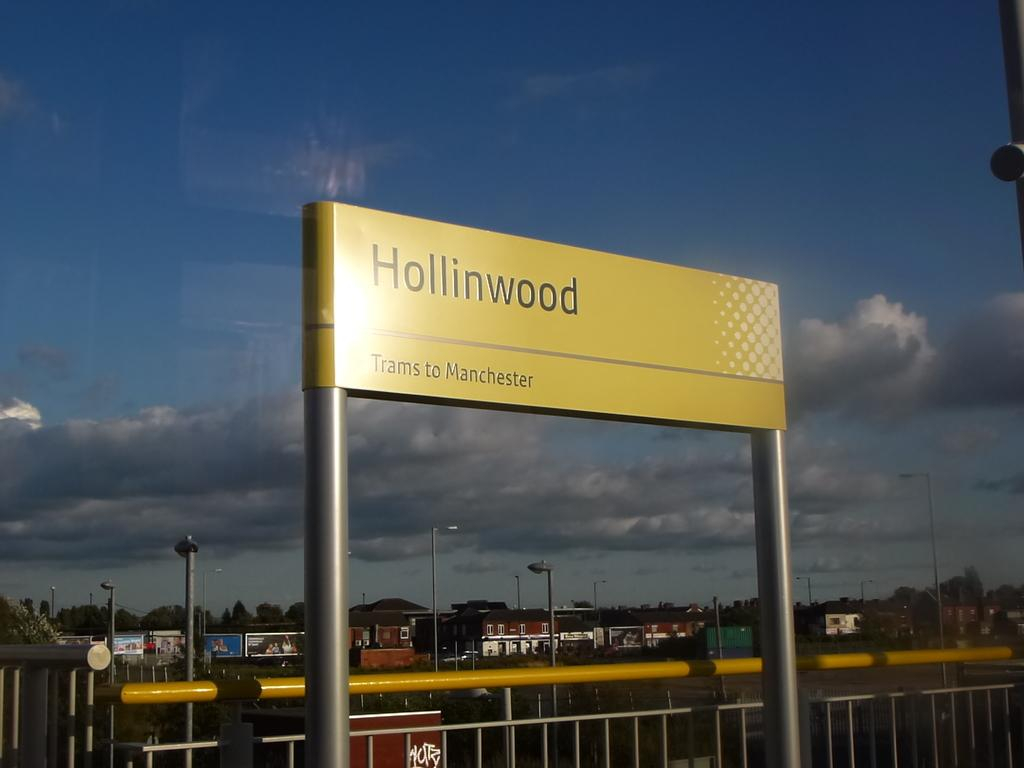<image>
Describe the image concisely. Yellow billboard saying trams are going to Manchester. 